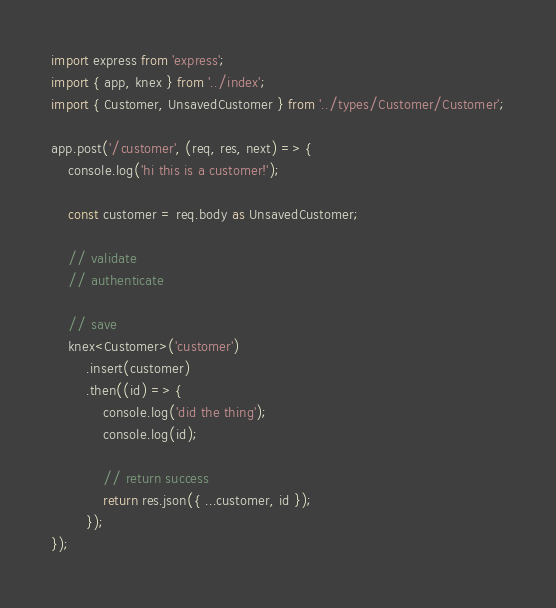<code> <loc_0><loc_0><loc_500><loc_500><_TypeScript_>import express from 'express';
import { app, knex } from '../index';
import { Customer, UnsavedCustomer } from '../types/Customer/Customer';

app.post('/customer', (req, res, next) => {
    console.log('hi this is a customer!');

    const customer = req.body as UnsavedCustomer;

    // validate
    // authenticate

    // save
    knex<Customer>('customer')
        .insert(customer)
        .then((id) => {
            console.log('did the thing');
            console.log(id);

            // return success
            return res.json({ ...customer, id });
        });
});
</code> 